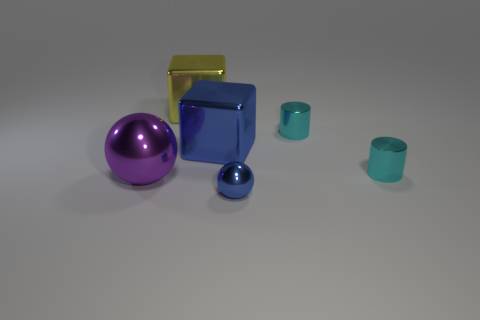Is the color of the small sphere the same as the big shiny object left of the yellow thing?
Provide a short and direct response. No. What number of other things are there of the same size as the purple metallic ball?
Your response must be concise. 2. The metal object to the right of the tiny cylinder that is behind the tiny cyan shiny cylinder in front of the large blue metallic block is what shape?
Provide a succinct answer. Cylinder. Does the yellow thing have the same size as the shiny ball that is right of the big purple shiny object?
Give a very brief answer. No. The big metallic object that is on the right side of the purple metallic sphere and in front of the big yellow metal object is what color?
Make the answer very short. Blue. What number of other objects are there of the same shape as the tiny blue metallic thing?
Offer a very short reply. 1. Do the big metallic object right of the big yellow metallic block and the ball that is behind the blue sphere have the same color?
Your response must be concise. No. Do the blue thing that is behind the big shiny sphere and the object that is in front of the large purple sphere have the same size?
Offer a terse response. No. Is there anything else that is made of the same material as the large ball?
Make the answer very short. Yes. There is a big thing that is in front of the cyan object in front of the blue thing behind the small metallic sphere; what is it made of?
Your answer should be compact. Metal. 